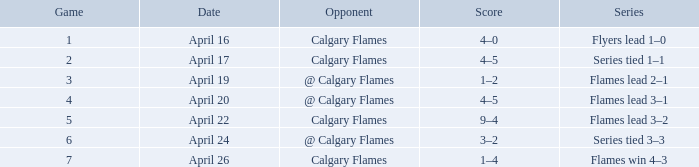Can you parse all the data within this table? {'header': ['Game', 'Date', 'Opponent', 'Score', 'Series'], 'rows': [['1', 'April 16', 'Calgary Flames', '4–0', 'Flyers lead 1–0'], ['2', 'April 17', 'Calgary Flames', '4–5', 'Series tied 1–1'], ['3', 'April 19', '@ Calgary Flames', '1–2', 'Flames lead 2–1'], ['4', 'April 20', '@ Calgary Flames', '4–5', 'Flames lead 3–1'], ['5', 'April 22', 'Calgary Flames', '9–4', 'Flames lead 3–2'], ['6', 'April 24', '@ Calgary Flames', '3–2', 'Series tied 3–3'], ['7', 'April 26', 'Calgary Flames', '1–4', 'Flames win 4–3']]} For which date is there a 4-5 score and a game size less than 4? April 17. 